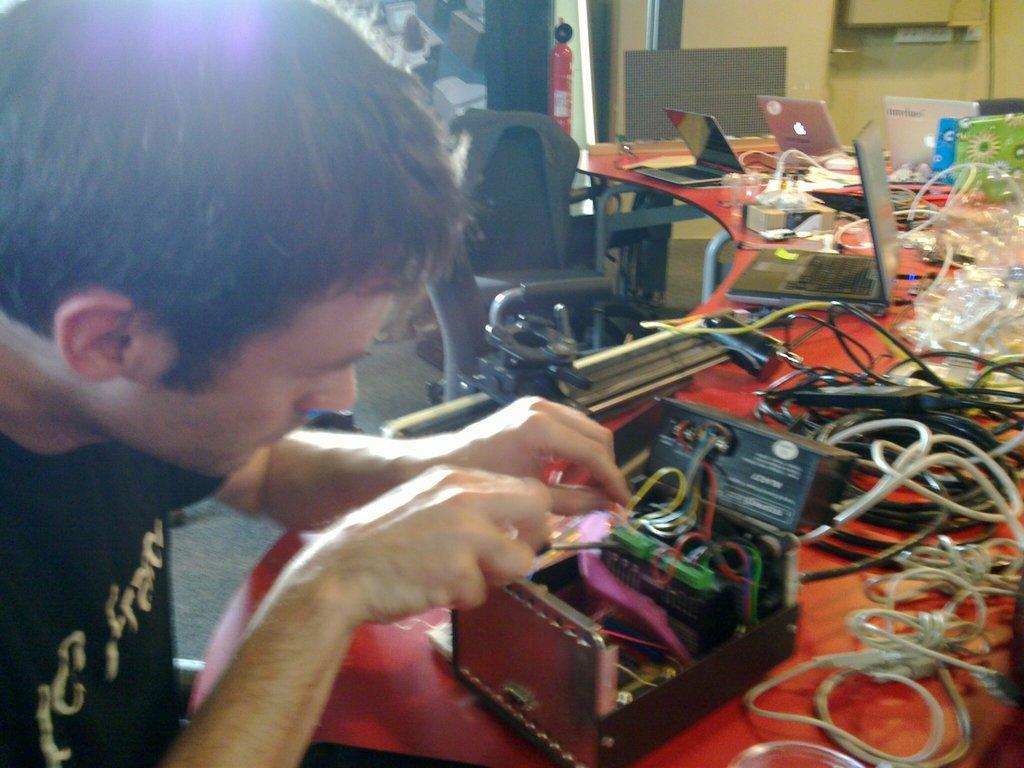Can you describe this image briefly? As we can see in the image there is a person's black black color t shirt. There is a wall, chair and table. On table there are wires, laptops, box and an electrical equipment. 